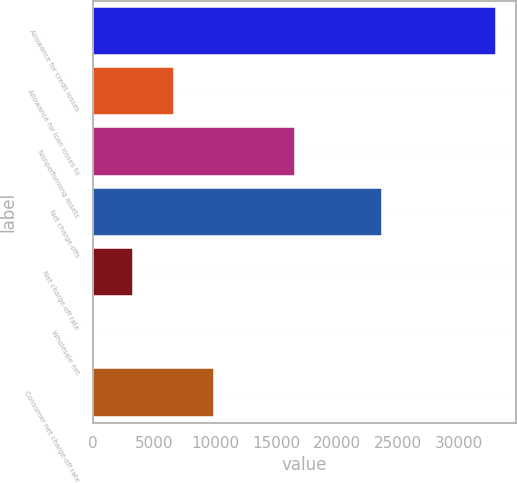Convert chart to OTSL. <chart><loc_0><loc_0><loc_500><loc_500><bar_chart><fcel>Allowance for credit losses<fcel>Allowance for loan losses to<fcel>Nonperforming assets<fcel>Net charge-offs<fcel>Net charge-off rate<fcel>Wholesale net<fcel>Consumer net charge-off rate<nl><fcel>32983<fcel>6597.25<fcel>16557<fcel>23673<fcel>3299.03<fcel>0.81<fcel>9895.47<nl></chart> 